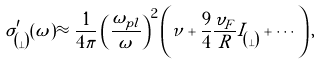<formula> <loc_0><loc_0><loc_500><loc_500>\sigma ^ { \prime } _ { \| \choose \bot } ( \omega ) \approx \frac { 1 } { 4 \pi } \left ( \frac { \omega _ { p l } } { \omega } \right ) ^ { 2 } \left ( \nu + \frac { 9 } { 4 } \frac { \upsilon _ { F } } { R } I _ { \| \choose \bot } + \cdots \right ) ,</formula> 